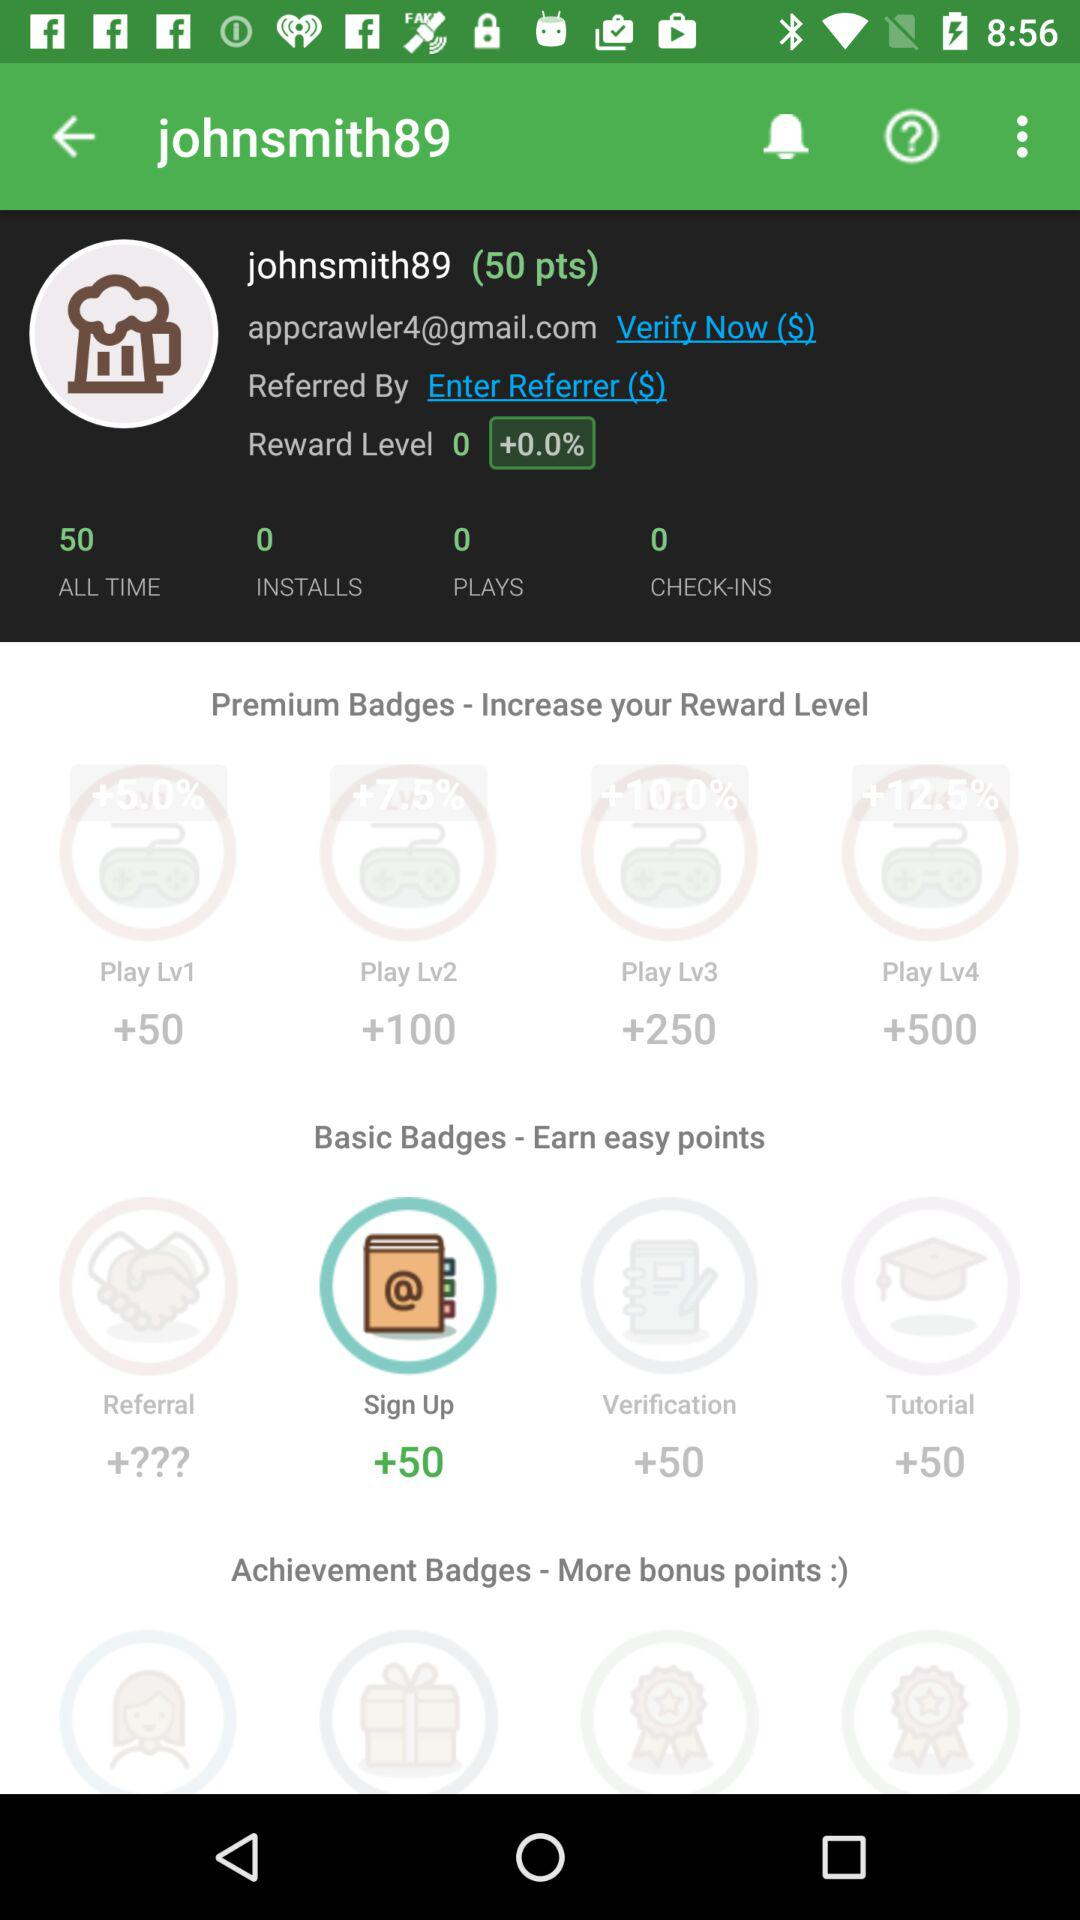How many more points do I need to reach reward level 1?
Answer the question using a single word or phrase. 50 